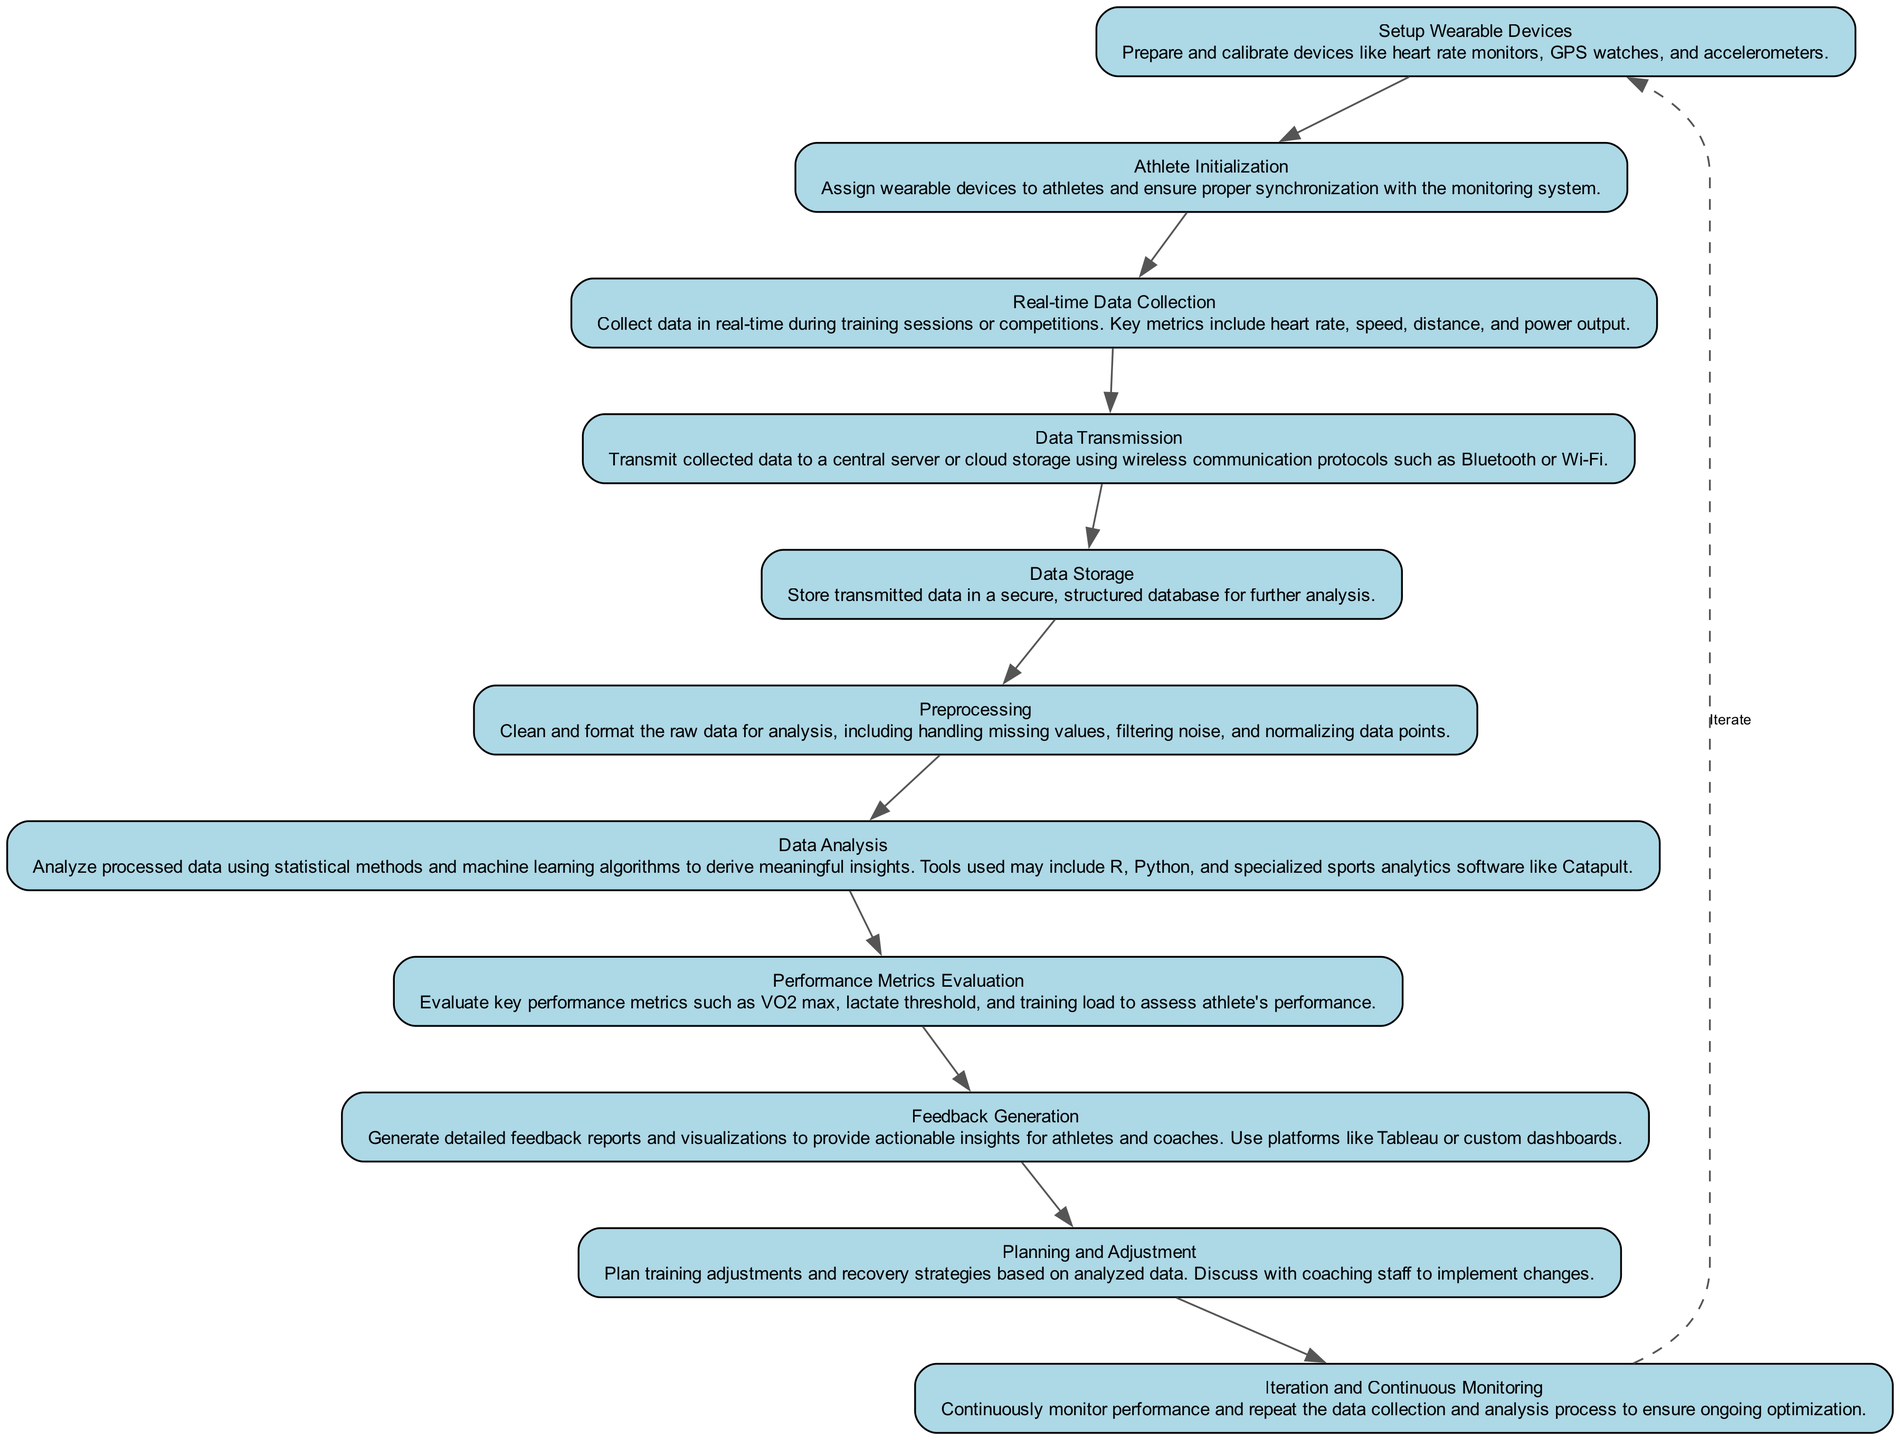What's the first step in the workflow? The diagram clearly shows that the first step is labeled "Setup Wearable Devices," indicating the initial task involves preparing and calibrating the devices.
Answer: Setup Wearable Devices How many steps are involved in this workflow? By counting the nodes in the diagram, we can confirm that there are a total of eleven steps, as there are eleven distinct elements listed.
Answer: Eleven What type of data is collected in real-time during training sessions? The description under "Real-time Data Collection" specifies that metrics like heart rate, speed, distance, and power output are collected, indicating the performance variables monitored during activities.
Answer: Heart rate, speed, distance, power output Which step comes immediately after "Data Storage"? Following the "Data Storage" step in the diagram, the next step is indicated as "Preprocessing," suggesting that data cleaning and formatting occur right after data is stored.
Answer: Preprocessing What is the purpose of "Feedback Generation"? The purpose of "Feedback Generation," as described, is to create detailed reports and visualizations that provide actionable insights for athletes and coaches, emphasizing its role in performance improvement.
Answer: To provide actionable insights How does the iteration process function in this workflow? The diagram illustrates that there is a dashed edge looping from "Iteration and Continuous Monitoring" back to "Setup Wearable Devices," indicating that the whole process is repeated continuously for ongoing performance optimization.
Answer: Continuously monitor performance and repeat process What technology is mentioned for analyzing data? The description under "Data Analysis" lists tools like R, Python, and specialized sports analytics software, which are the technologies utilized for in-depth analysis.
Answer: R, Python, Catapult What comes after "Performance Metrics Evaluation"? After "Performance Metrics Evaluation," the workflow continues with "Feedback Generation," indicating the progression from evaluating performance to generating feedback.
Answer: Feedback Generation Which step includes cleaning and formatting raw data? The description clearly states that the "Preprocessing" step involves cleaning and formatting raw data before it is analyzed, identifying this phase's importance in data preparation.
Answer: Preprocessing 